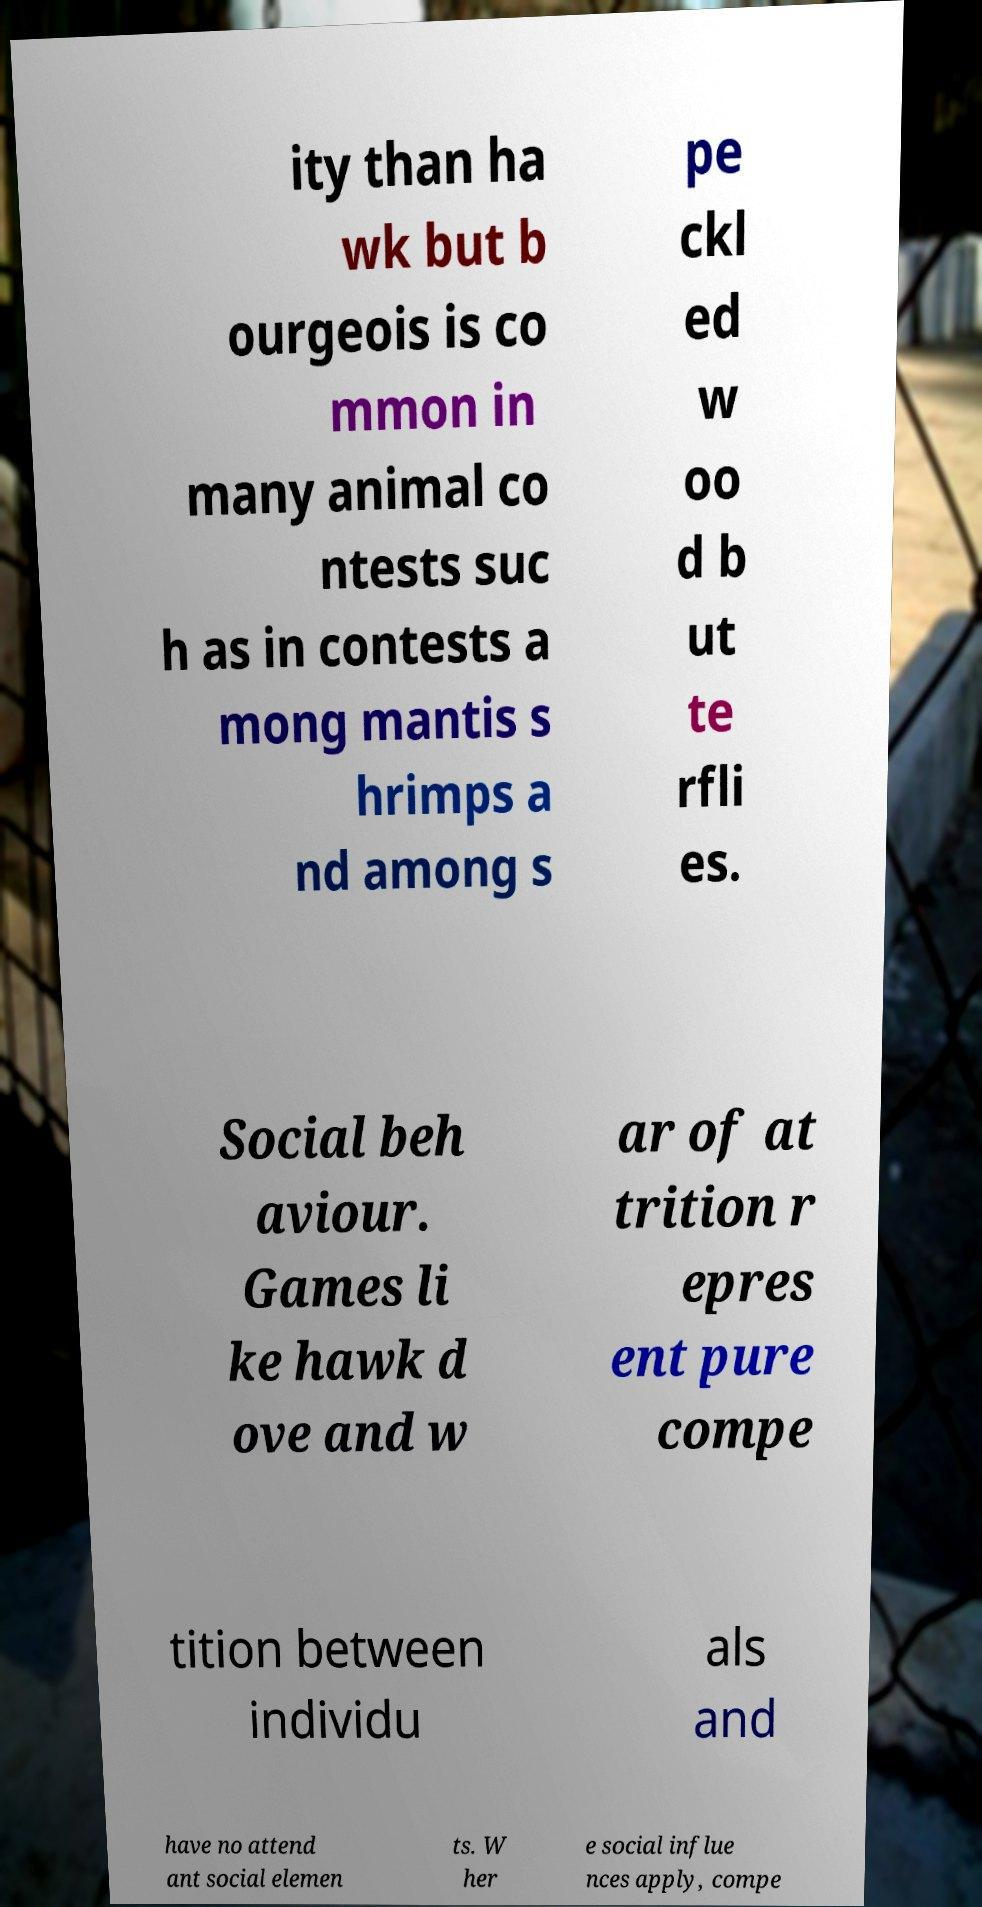Please identify and transcribe the text found in this image. ity than ha wk but b ourgeois is co mmon in many animal co ntests suc h as in contests a mong mantis s hrimps a nd among s pe ckl ed w oo d b ut te rfli es. Social beh aviour. Games li ke hawk d ove and w ar of at trition r epres ent pure compe tition between individu als and have no attend ant social elemen ts. W her e social influe nces apply, compe 